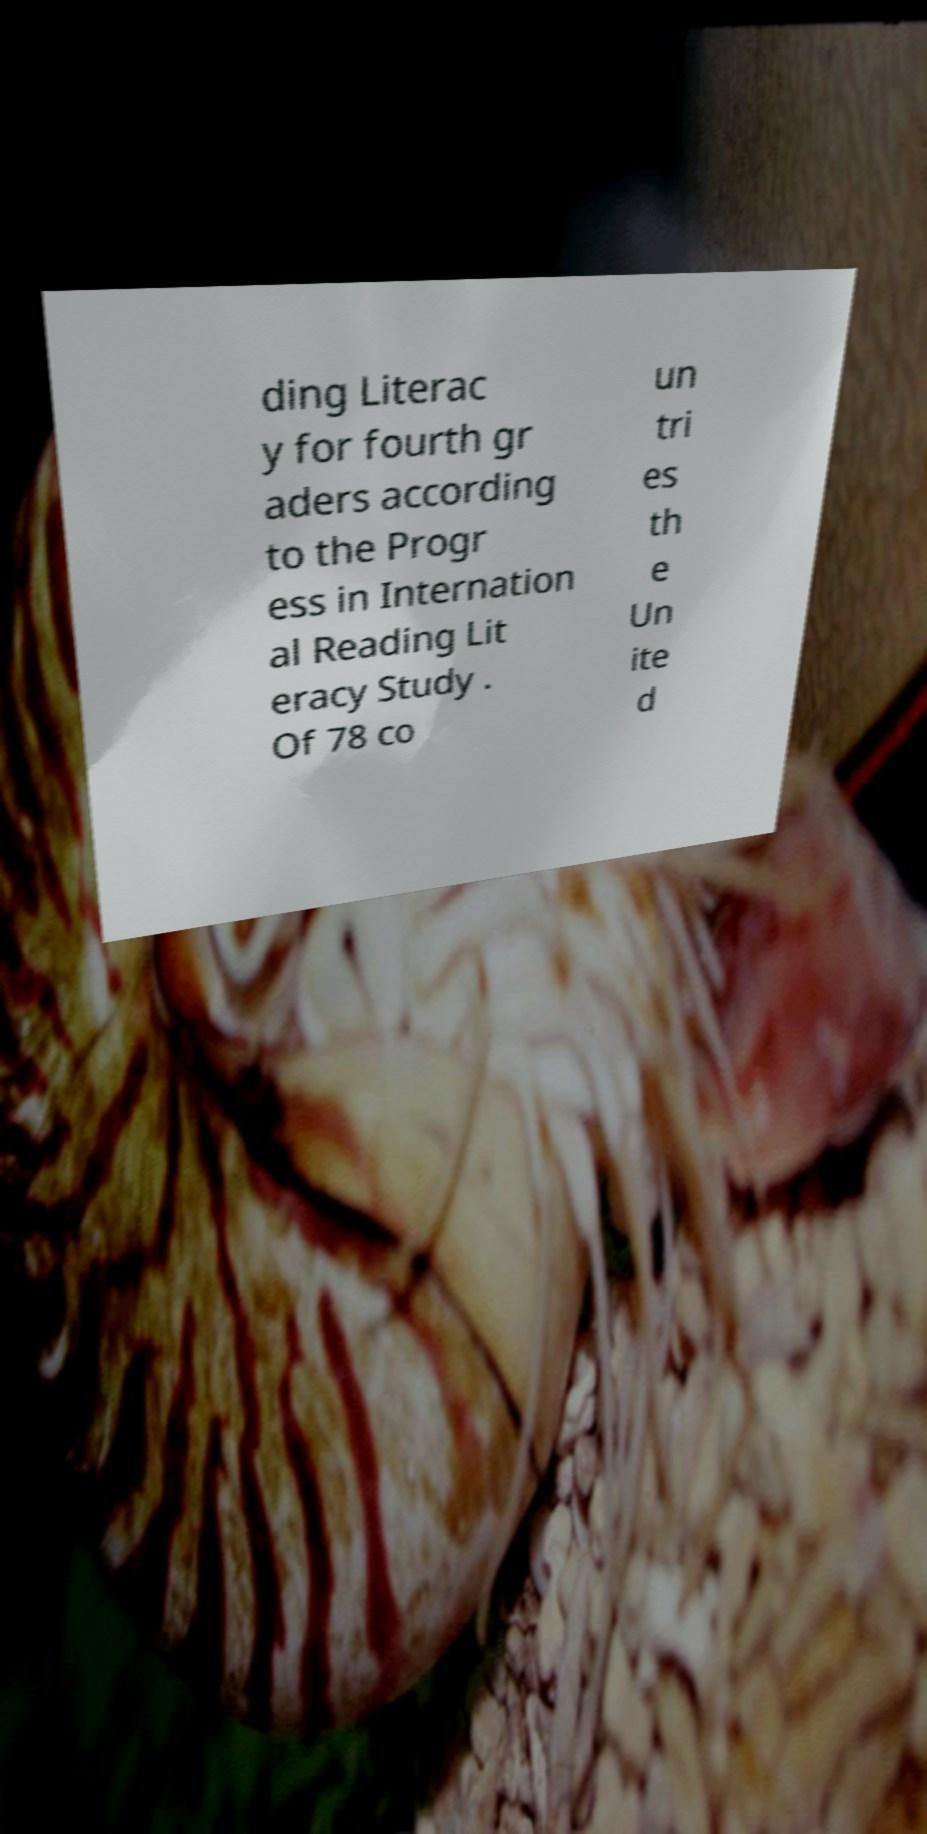Could you assist in decoding the text presented in this image and type it out clearly? ding Literac y for fourth gr aders according to the Progr ess in Internation al Reading Lit eracy Study . Of 78 co un tri es th e Un ite d 